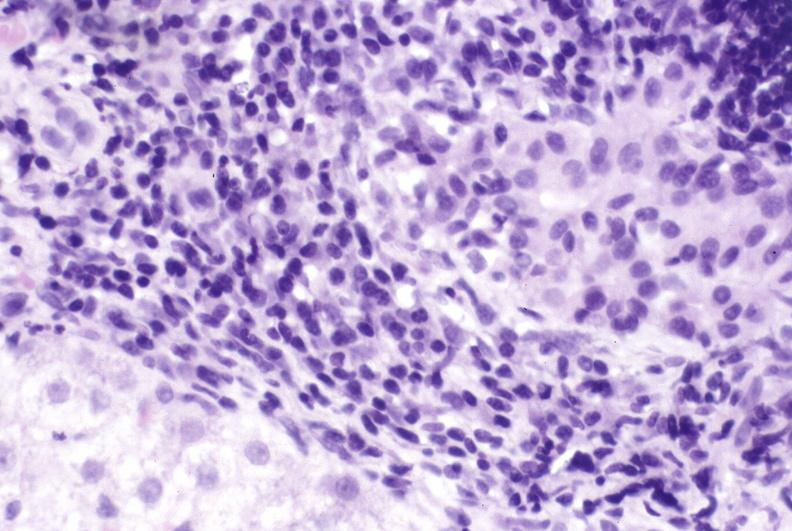s liver present?
Answer the question using a single word or phrase. Yes 